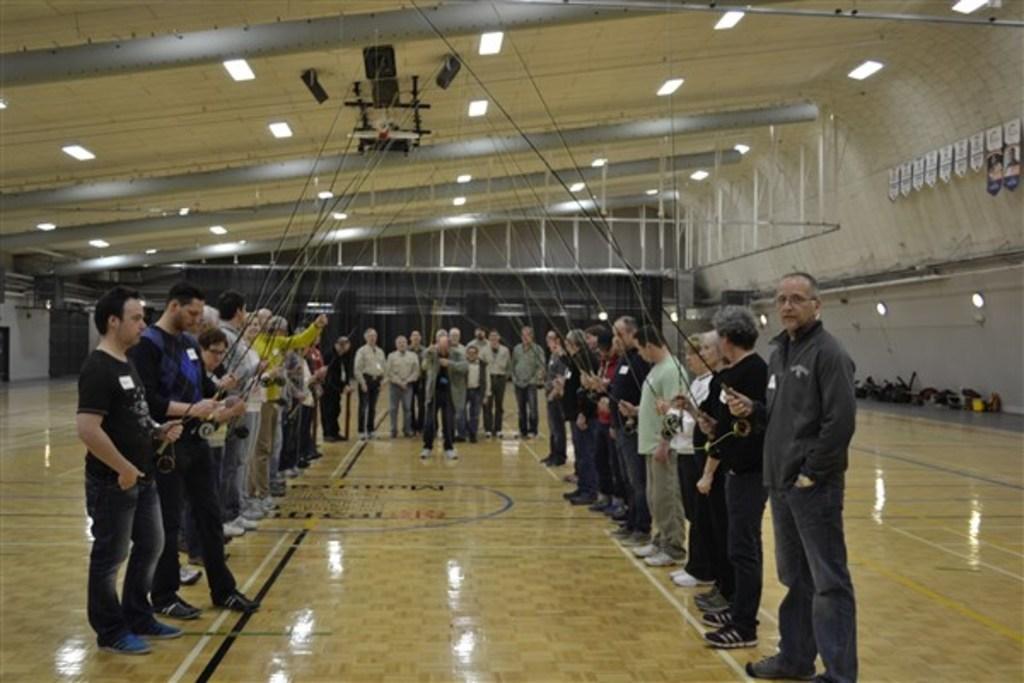Could you give a brief overview of what you see in this image? This picture is taken in a room. In the center of the picture there are people standing holding fishnets. This is a wooden floor. At the top to the ceiling there are lights and iron bars. On the right there are banners, lights. 